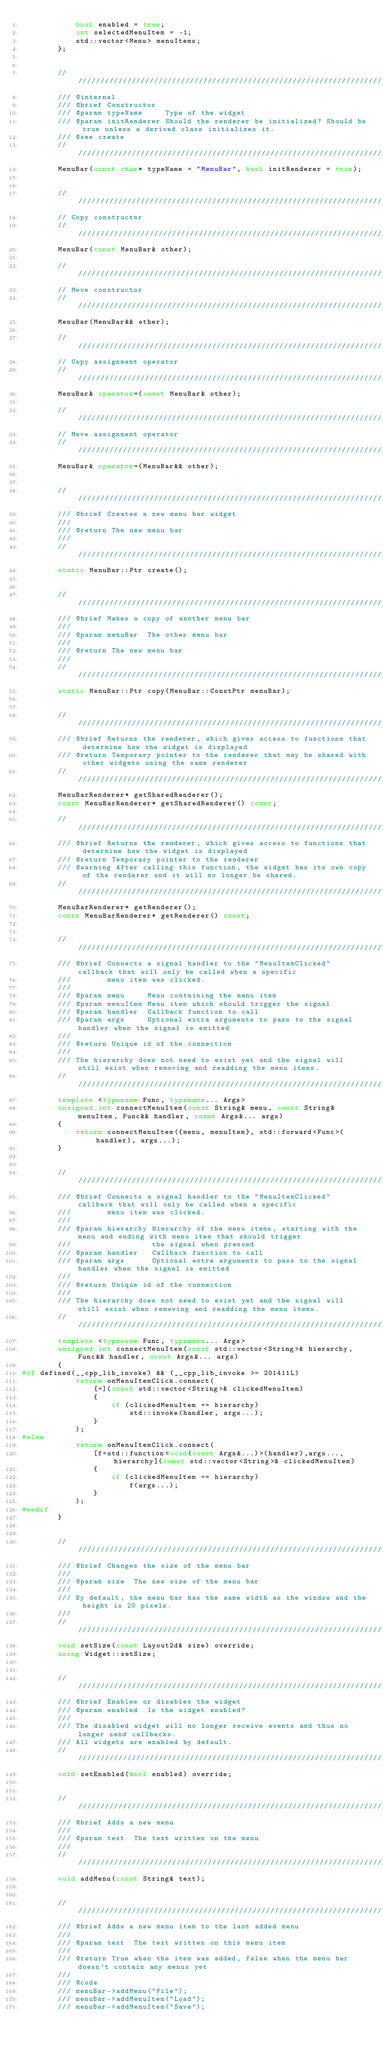<code> <loc_0><loc_0><loc_500><loc_500><_C++_>            bool enabled = true;
            int selectedMenuItem = -1;
            std::vector<Menu> menuItems;
        };


        /////////////////////////////////////////////////////////////////////////////////////////////////////////////////////////
        /// @internal
        /// @brief Constructor
        /// @param typeName     Type of the widget
        /// @param initRenderer Should the renderer be initialized? Should be true unless a derived class initializes it.
        /// @see create
        /////////////////////////////////////////////////////////////////////////////////////////////////////////////////////////
        MenuBar(const char* typeName = "MenuBar", bool initRenderer = true);


        /////////////////////////////////////////////////////////////////////////////////////////////////////////////////////////
        // Copy constructor
        /////////////////////////////////////////////////////////////////////////////////////////////////////////////////////////
        MenuBar(const MenuBar& other);

        /////////////////////////////////////////////////////////////////////////////////////////////////////////////////////////
        // Move constructor
        /////////////////////////////////////////////////////////////////////////////////////////////////////////////////////////
        MenuBar(MenuBar&& other);

        /////////////////////////////////////////////////////////////////////////////////////////////////////////////////////////
        // Copy assignment operator
        /////////////////////////////////////////////////////////////////////////////////////////////////////////////////////////
        MenuBar& operator=(const MenuBar& other);

        /////////////////////////////////////////////////////////////////////////////////////////////////////////////////////////
        // Move assignment operator
        /////////////////////////////////////////////////////////////////////////////////////////////////////////////////////////
        MenuBar& operator=(MenuBar&& other);


        /////////////////////////////////////////////////////////////////////////////////////////////////////////////////////////
        /// @brief Creates a new menu bar widget
        ///
        /// @return The new menu bar
        ///
        /////////////////////////////////////////////////////////////////////////////////////////////////////////////////////////
        static MenuBar::Ptr create();


        /////////////////////////////////////////////////////////////////////////////////////////////////////////////////////////
        /// @brief Makes a copy of another menu bar
        ///
        /// @param menuBar  The other menu bar
        ///
        /// @return The new menu bar
        ///
        /////////////////////////////////////////////////////////////////////////////////////////////////////////////////////////
        static MenuBar::Ptr copy(MenuBar::ConstPtr menuBar);


        /////////////////////////////////////////////////////////////////////////////////////////////////////////////////////////
        /// @brief Returns the renderer, which gives access to functions that determine how the widget is displayed
        /// @return Temporary pointer to the renderer that may be shared with other widgets using the same renderer
        /////////////////////////////////////////////////////////////////////////////////////////////////////////////////////////
        MenuBarRenderer* getSharedRenderer();
        const MenuBarRenderer* getSharedRenderer() const;

        /////////////////////////////////////////////////////////////////////////////////////////////////////////////////////////
        /// @brief Returns the renderer, which gives access to functions that determine how the widget is displayed
        /// @return Temporary pointer to the renderer
        /// @warning After calling this function, the widget has its own copy of the renderer and it will no longer be shared.
        /////////////////////////////////////////////////////////////////////////////////////////////////////////////////////////
        MenuBarRenderer* getRenderer();
        const MenuBarRenderer* getRenderer() const;


        /////////////////////////////////////////////////////////////////////////////////////////////////////////////////////////
        /// @brief Connects a signal handler to the "MenuItemClicked" callback that will only be called when a specific
        ///        menu item was clicked.
        ///
        /// @param menu     Menu containing the menu item
        /// @param menuItem Menu item which should trigger the signal
        /// @param handler  Callback function to call
        /// @param args     Optional extra arguments to pass to the signal handler when the signal is emitted
        ///
        /// @return Unique id of the connection
        ///
        /// The hierarchy does not need to exist yet and the signal will still exist when removing and readding the menu items.
        /////////////////////////////////////////////////////////////////////////////////////////////////////////////////////////
        template <typename Func, typename... Args>
        unsigned int connectMenuItem(const String& menu, const String& menuItem, Func&& handler, const Args&... args)
        {
            return connectMenuItem({menu, menuItem}, std::forward<Func>(handler), args...);
        }


        /////////////////////////////////////////////////////////////////////////////////////////////////////////////////////////
        /// @brief Connects a signal handler to the "MenuItemClicked" callback that will only be called when a specific
        ///        menu item was clicked.
        ///
        /// @param hierarchy Hierarchy of the menu items, starting with the menu and ending with menu item that should trigger
        ///                  the signal when pressed
        /// @param handler   Callback function to call
        /// @param args      Optional extra arguments to pass to the signal handler when the signal is emitted
        ///
        /// @return Unique id of the connection
        ///
        /// The hierarchy does not need to exist yet and the signal will still exist when removing and readding the menu items.
        /////////////////////////////////////////////////////////////////////////////////////////////////////////////////////////
        template <typename Func, typename... Args>
        unsigned int connectMenuItem(const std::vector<String>& hierarchy, Func&& handler, const Args&... args)
        {
#if defined(__cpp_lib_invoke) && (__cpp_lib_invoke >= 201411L)
            return onMenuItemClick.connect(
                [=](const std::vector<String>& clickedMenuItem)
                {
                    if (clickedMenuItem == hierarchy)
                        std::invoke(handler, args...);
                }
            );
#else
            return onMenuItemClick.connect(
                [f=std::function<void(const Args&...)>(handler),args...,hierarchy](const std::vector<String>& clickedMenuItem)
                {
                    if (clickedMenuItem == hierarchy)
                        f(args...);
                }
            );
#endif
        }


        /////////////////////////////////////////////////////////////////////////////////////////////////////////////////////////
        /// @brief Changes the size of the menu bar
        ///
        /// @param size  The new size of the menu bar
        ///
        /// By default, the menu bar has the same width as the window and the height is 20 pixels.
        ///
        /////////////////////////////////////////////////////////////////////////////////////////////////////////////////////////
        void setSize(const Layout2d& size) override;
        using Widget::setSize;


        /////////////////////////////////////////////////////////////////////////////////////////////////////////////////////////
        /// @brief Enables or disables the widget
        /// @param enabled  Is the widget enabled?
        ///
        /// The disabled widget will no longer receive events and thus no longer send callbacks.
        /// All widgets are enabled by default.
        /////////////////////////////////////////////////////////////////////////////////////////////////////////////////////////
        void setEnabled(bool enabled) override;


        /////////////////////////////////////////////////////////////////////////////////////////////////////////////////////////
        /// @brief Adds a new menu
        ///
        /// @param text  The text written on the menu
        ///
        /////////////////////////////////////////////////////////////////////////////////////////////////////////////////////////
        void addMenu(const String& text);


        /////////////////////////////////////////////////////////////////////////////////////////////////////////////////////////
        /// @brief Adds a new menu item to the last added menu
        ///
        /// @param text  The text written on this menu item
        ///
        /// @return True when the item was added, false when the menu bar doesn't contain any menus yet
        ///
        /// @code
        /// menuBar->addMenu("File");
        /// menuBar->addMenuItem("Load");
        /// menuBar->addMenuItem("Save");</code> 